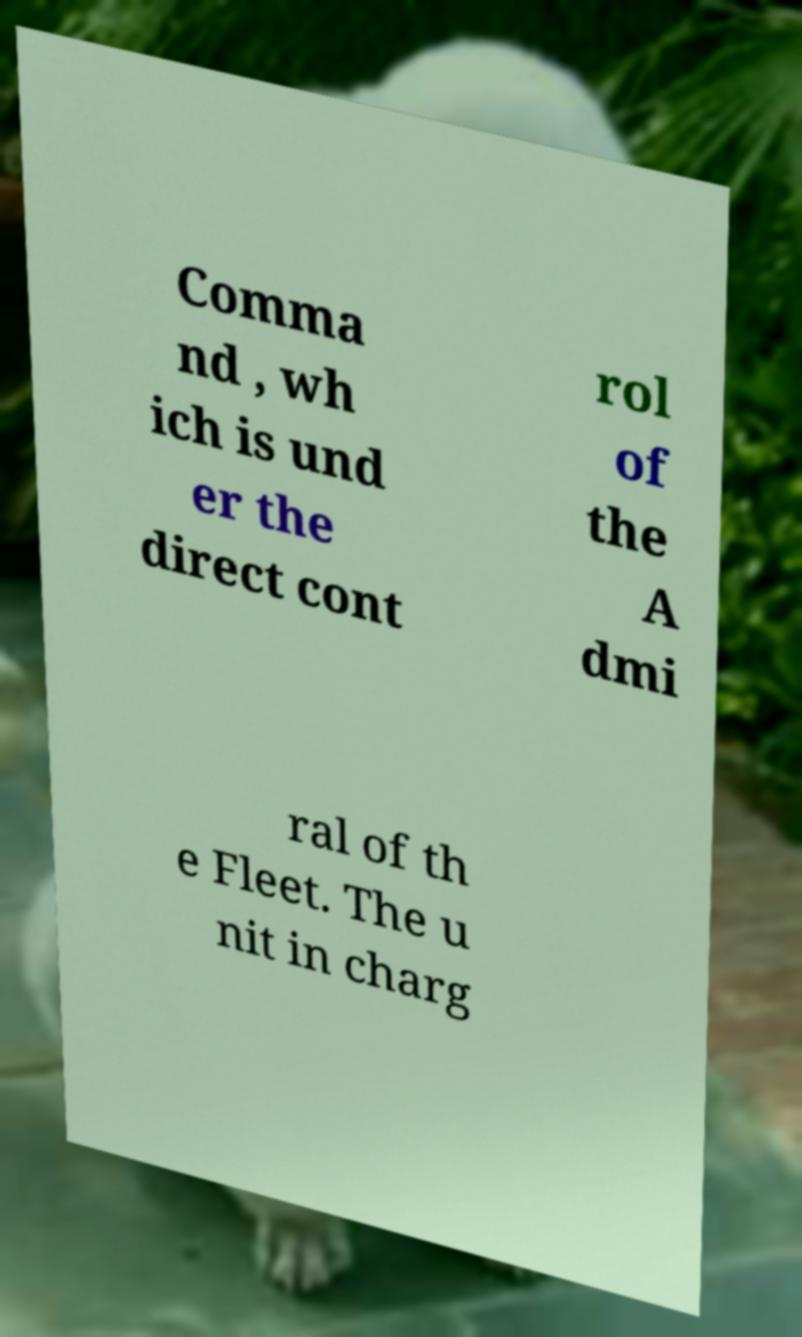There's text embedded in this image that I need extracted. Can you transcribe it verbatim? Comma nd , wh ich is und er the direct cont rol of the A dmi ral of th e Fleet. The u nit in charg 